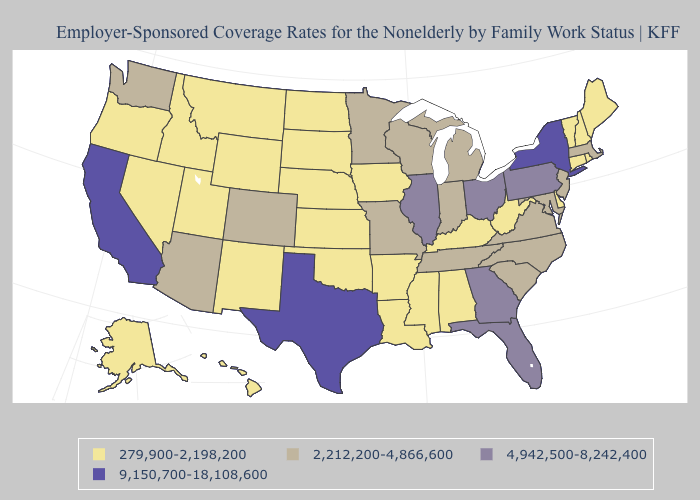Does Minnesota have a lower value than Connecticut?
Be succinct. No. Does Texas have the highest value in the USA?
Keep it brief. Yes. Which states hav the highest value in the Northeast?
Short answer required. New York. Does the first symbol in the legend represent the smallest category?
Keep it brief. Yes. Does the map have missing data?
Be succinct. No. What is the highest value in states that border Illinois?
Give a very brief answer. 2,212,200-4,866,600. Name the states that have a value in the range 4,942,500-8,242,400?
Be succinct. Florida, Georgia, Illinois, Ohio, Pennsylvania. Name the states that have a value in the range 4,942,500-8,242,400?
Concise answer only. Florida, Georgia, Illinois, Ohio, Pennsylvania. What is the value of Virginia?
Keep it brief. 2,212,200-4,866,600. Does Minnesota have a higher value than Louisiana?
Write a very short answer. Yes. Name the states that have a value in the range 9,150,700-18,108,600?
Keep it brief. California, New York, Texas. Does the first symbol in the legend represent the smallest category?
Write a very short answer. Yes. Name the states that have a value in the range 2,212,200-4,866,600?
Answer briefly. Arizona, Colorado, Indiana, Maryland, Massachusetts, Michigan, Minnesota, Missouri, New Jersey, North Carolina, South Carolina, Tennessee, Virginia, Washington, Wisconsin. What is the value of Vermont?
Keep it brief. 279,900-2,198,200. Name the states that have a value in the range 279,900-2,198,200?
Keep it brief. Alabama, Alaska, Arkansas, Connecticut, Delaware, Hawaii, Idaho, Iowa, Kansas, Kentucky, Louisiana, Maine, Mississippi, Montana, Nebraska, Nevada, New Hampshire, New Mexico, North Dakota, Oklahoma, Oregon, Rhode Island, South Dakota, Utah, Vermont, West Virginia, Wyoming. 